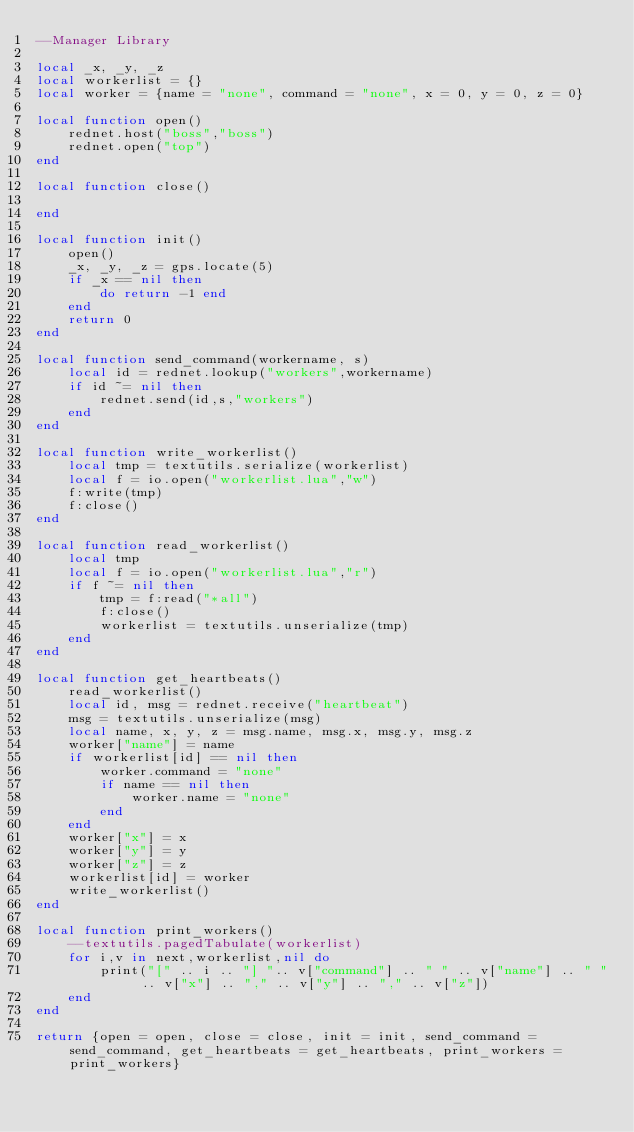Convert code to text. <code><loc_0><loc_0><loc_500><loc_500><_Lua_>--Manager Library

local _x, _y, _z
local workerlist = {}
local worker = {name = "none", command = "none", x = 0, y = 0, z = 0}

local function open()
    rednet.host("boss","boss")
    rednet.open("top")
end

local function close()

end

local function init()
    open()
    _x, _y, _z = gps.locate(5)
    if _x == nil then
        do return -1 end
    end
    return 0
end

local function send_command(workername, s)
    local id = rednet.lookup("workers",workername)
    if id ~= nil then
        rednet.send(id,s,"workers")
    end
end

local function write_workerlist()
    local tmp = textutils.serialize(workerlist)
    local f = io.open("workerlist.lua","w")
    f:write(tmp)
    f:close()
end

local function read_workerlist()
    local tmp
    local f = io.open("workerlist.lua","r")
    if f ~= nil then
        tmp = f:read("*all")
        f:close()
        workerlist = textutils.unserialize(tmp)
    end
end

local function get_heartbeats()
    read_workerlist()
    local id, msg = rednet.receive("heartbeat")
    msg = textutils.unserialize(msg)
    local name, x, y, z = msg.name, msg.x, msg.y, msg.z
    worker["name"] = name
    if workerlist[id] == nil then
        worker.command = "none"
        if name == nil then
            worker.name = "none"
        end
    end
    worker["x"] = x
    worker["y"] = y
    worker["z"] = z
    workerlist[id] = worker
    write_workerlist()
end

local function print_workers()
    --textutils.pagedTabulate(workerlist)
    for i,v in next,workerlist,nil do
        print("[" .. i .. "] ".. v["command"] .. " " .. v["name"] .. " " .. v["x"] .. "," .. v["y"] .. "," .. v["z"])
    end
end

return {open = open, close = close, init = init, send_command = send_command, get_heartbeats = get_heartbeats, print_workers = print_workers}</code> 